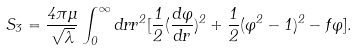Convert formula to latex. <formula><loc_0><loc_0><loc_500><loc_500>S _ { 3 } = \frac { 4 \pi \mu } { \sqrt { \lambda } } \int _ { 0 } ^ { \infty } d r r ^ { 2 } [ \frac { 1 } { 2 } ( \frac { d \varphi } { d r } ) ^ { 2 } + \frac { 1 } { 2 } ( \varphi ^ { 2 } - 1 ) ^ { 2 } - f \varphi ] .</formula> 